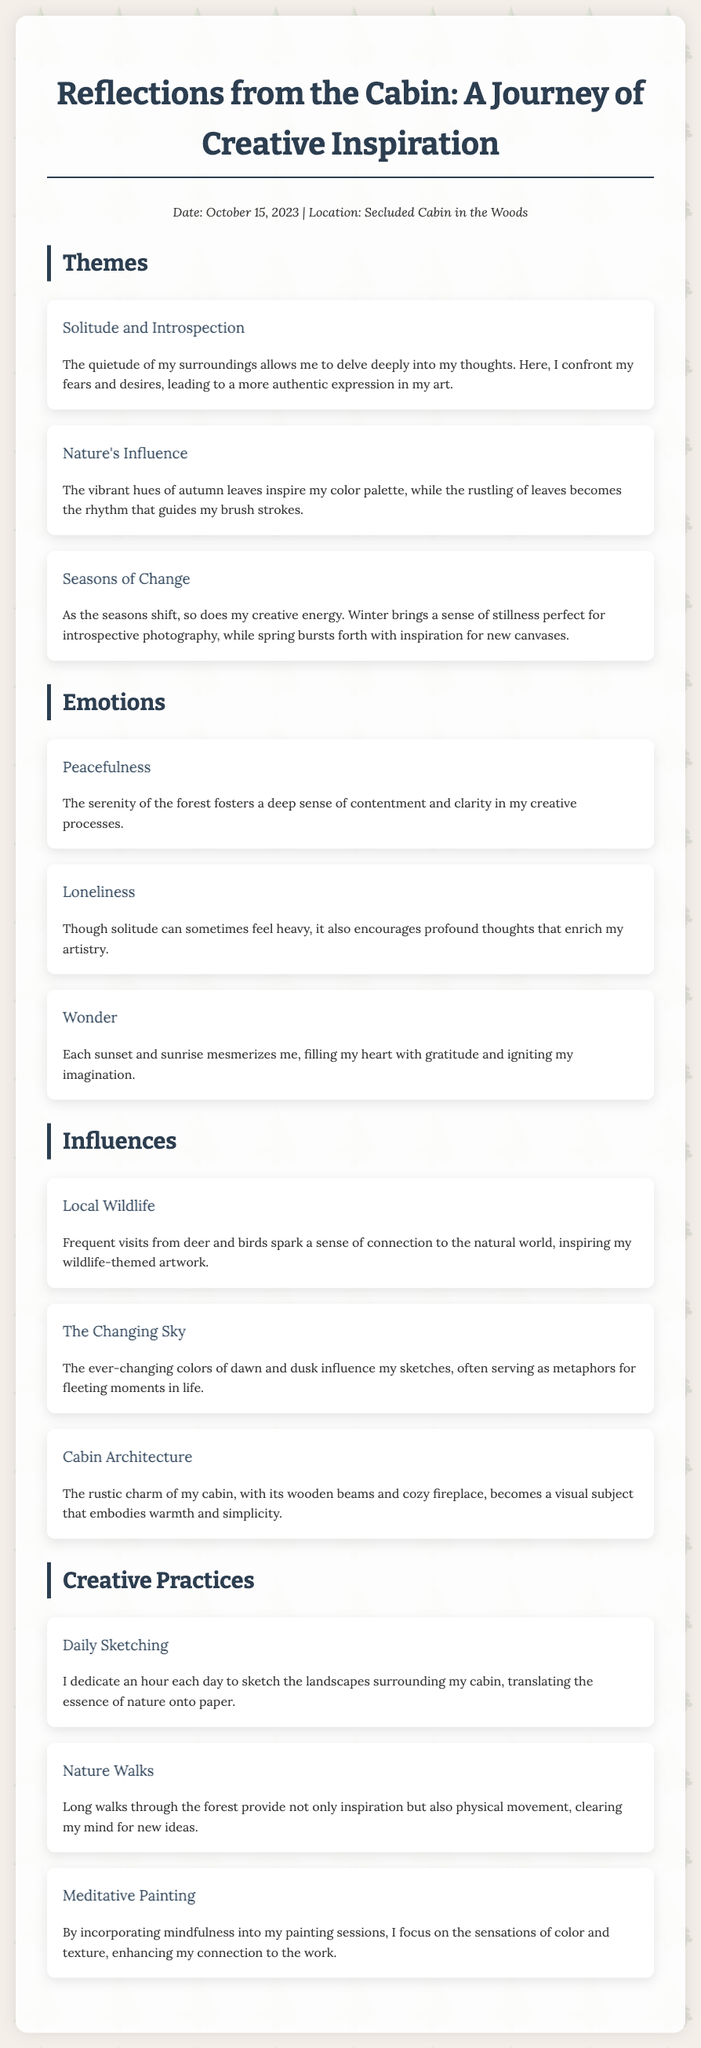What is the date of the journal entry? The date of the journal entry is clearly stated in the meta section of the document.
Answer: October 15, 2023 What is the primary location of the writer? The location can be found in the same meta section, indicating where the thoughts were expressed.
Answer: Secluded Cabin in the Woods What theme does the writer associate with solitude? The theme can be found in the section dedicated to themes, focusing on the writer's introspective process.
Answer: Introspection How does the writer feel about the changing seasons? This is addressed in the themes section discussing the impact of seasons on creativity.
Answer: Creative energy What emotion is described alongside loneliness? The emotions section provides insight into the writer's feelings, including the complexity of solitude.
Answer: Profound thoughts What wildlife is mentioned in relation to creativity? The influences section mentions specific animals that connect the writer to nature.
Answer: Deer and birds What creative practice involves being outdoors? This practice is discussed in the creative practices section, focusing on activities outside the cabin.
Answer: Nature Walks What aspect of the cabin serves as a visual subject? The influences section mentions the aesthetic qualities of the cabin that inspire the writer's art.
Answer: Rustic charm What is the theme of the emotional response to sunsets? The emotions section highlights an inspiring response to natural phenomena.
Answer: Wonder 